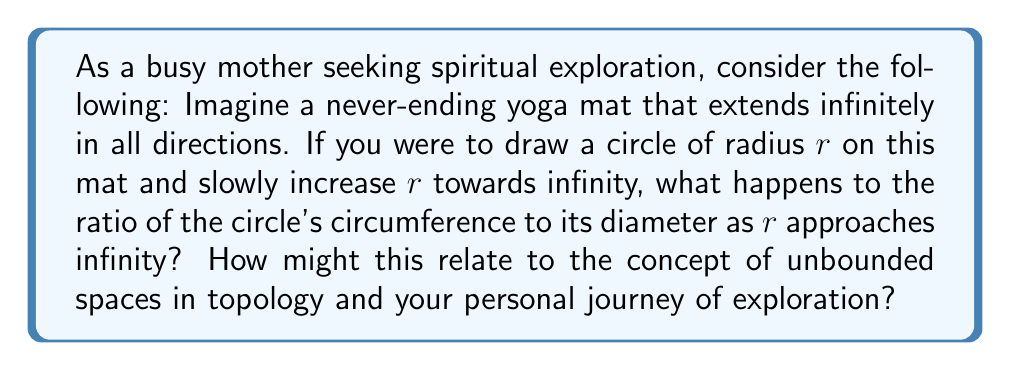Solve this math problem. Let's approach this step-by-step:

1) First, recall the formula for the circumference of a circle: $C = 2\pi r$, where $r$ is the radius.

2) The diameter of a circle is twice its radius: $d = 2r$

3) The ratio of circumference to diameter is:

   $$\frac{C}{d} = \frac{2\pi r}{2r} = \pi$$

4) As we increase $r$ towards infinity, this ratio remains constant at $\pi$.

5) In topology, an unbounded space is one that extends infinitely, much like our yoga mat. The circle on this mat, no matter how large, always maintains the same ratio of circumference to diameter.

6) This constant ratio, $\pi$, represents a fundamental truth about circles that holds even as we approach infinity. It's a concept that transcends size and scale.

7) From a spiritual perspective, this could be seen as a metaphor for universal truths or principles that remain constant regardless of our personal growth or the scale at which we view the universe.

8) The unbounded nature of the space (the infinite yoga mat) allows for endless exploration, much like one's spiritual journey. Yet, certain fundamental truths (like $\pi$) remain constant throughout this journey.
Answer: The ratio of the circle's circumference to its diameter remains constant at $\pi$, even as $r$ approaches infinity. This illustrates how certain mathematical truths persist in unbounded spaces, potentially serving as a metaphor for enduring principles discovered in one's spiritual exploration. 